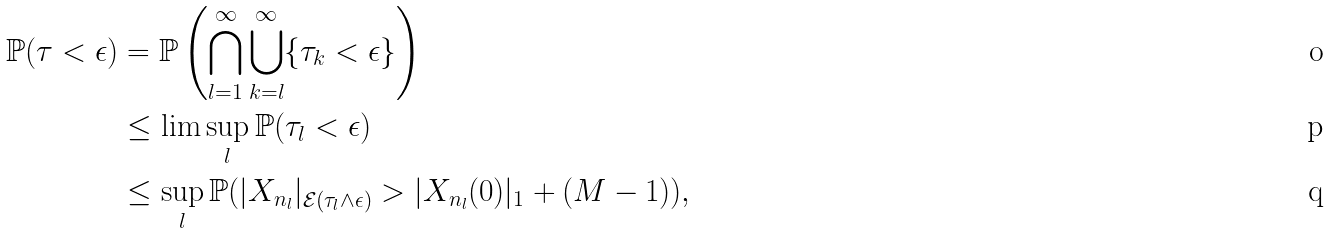Convert formula to latex. <formula><loc_0><loc_0><loc_500><loc_500>\mathbb { P } ( \tau < \epsilon ) & = \mathbb { P } \left ( \bigcap _ { l = 1 } ^ { \infty } \bigcup _ { k = l } ^ { \infty } \{ \tau _ { k } < \epsilon \} \right ) \\ & \leq \lim \sup _ { l } \mathbb { P } ( \tau _ { l } < \epsilon ) \\ & \leq \sup _ { l } \mathbb { P } ( | X _ { n _ { l } } | _ { \mathcal { E } ( \tau _ { l } \wedge \epsilon ) } > | X _ { n _ { l } } ( 0 ) | _ { 1 } + ( M - 1 ) ) ,</formula> 